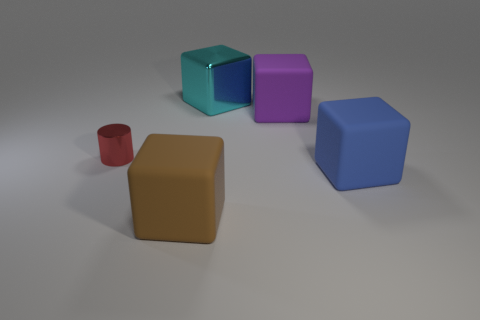Subtract 1 cubes. How many cubes are left? 3 Subtract all rubber blocks. How many blocks are left? 1 Subtract all gray cubes. Subtract all red cylinders. How many cubes are left? 4 Add 5 large cyan metallic blocks. How many objects exist? 10 Subtract all cylinders. How many objects are left? 4 Subtract 1 brown blocks. How many objects are left? 4 Subtract all rubber objects. Subtract all small blue cylinders. How many objects are left? 2 Add 2 large cyan blocks. How many large cyan blocks are left? 3 Add 1 tiny cyan metallic spheres. How many tiny cyan metallic spheres exist? 1 